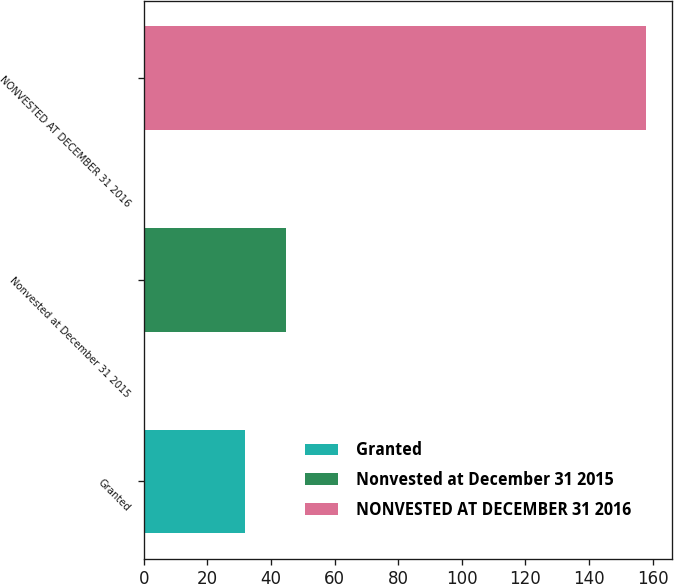<chart> <loc_0><loc_0><loc_500><loc_500><bar_chart><fcel>Granted<fcel>Nonvested at December 31 2015<fcel>NONVESTED AT DECEMBER 31 2016<nl><fcel>32<fcel>44.6<fcel>158<nl></chart> 